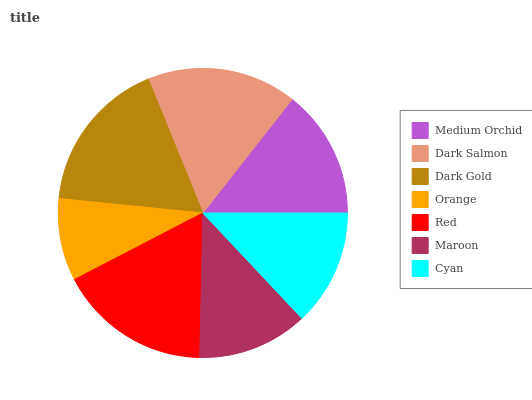Is Orange the minimum?
Answer yes or no. Yes. Is Dark Gold the maximum?
Answer yes or no. Yes. Is Dark Salmon the minimum?
Answer yes or no. No. Is Dark Salmon the maximum?
Answer yes or no. No. Is Dark Salmon greater than Medium Orchid?
Answer yes or no. Yes. Is Medium Orchid less than Dark Salmon?
Answer yes or no. Yes. Is Medium Orchid greater than Dark Salmon?
Answer yes or no. No. Is Dark Salmon less than Medium Orchid?
Answer yes or no. No. Is Medium Orchid the high median?
Answer yes or no. Yes. Is Medium Orchid the low median?
Answer yes or no. Yes. Is Dark Gold the high median?
Answer yes or no. No. Is Cyan the low median?
Answer yes or no. No. 